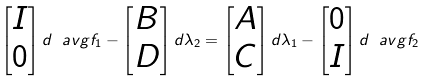<formula> <loc_0><loc_0><loc_500><loc_500>\begin{bmatrix} I \\ 0 \end{bmatrix} d \ a v g { f } _ { 1 } - \begin{bmatrix} B \\ D \end{bmatrix} d \lambda _ { 2 } = \begin{bmatrix} A \\ C \end{bmatrix} d \lambda _ { 1 } - \begin{bmatrix} 0 \\ I \end{bmatrix} d \ a v g { f } _ { 2 }</formula> 